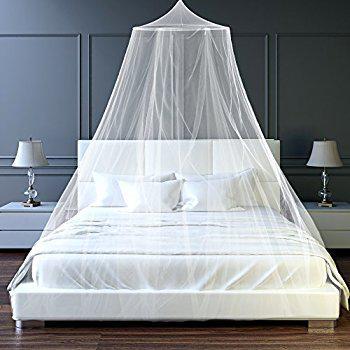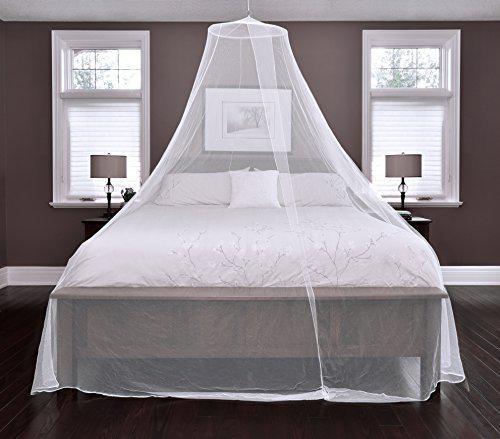The first image is the image on the left, the second image is the image on the right. Considering the images on both sides, is "There are two circle canopies." valid? Answer yes or no. Yes. 